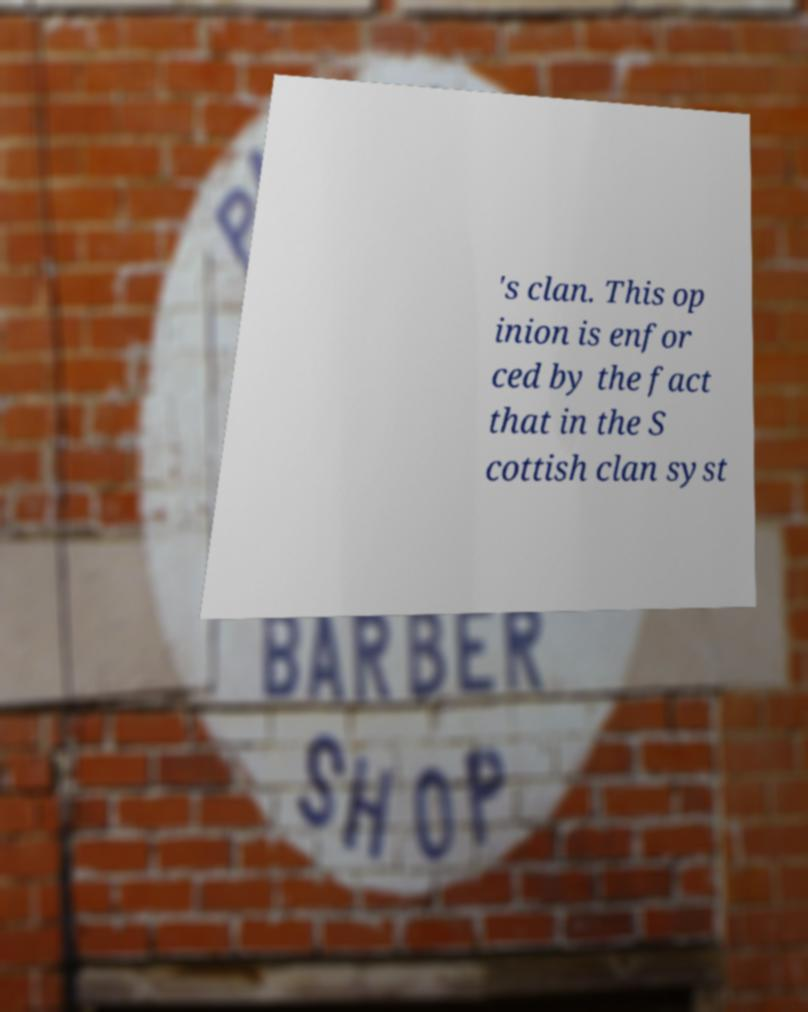There's text embedded in this image that I need extracted. Can you transcribe it verbatim? 's clan. This op inion is enfor ced by the fact that in the S cottish clan syst 